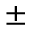Convert formula to latex. <formula><loc_0><loc_0><loc_500><loc_500>\pm</formula> 